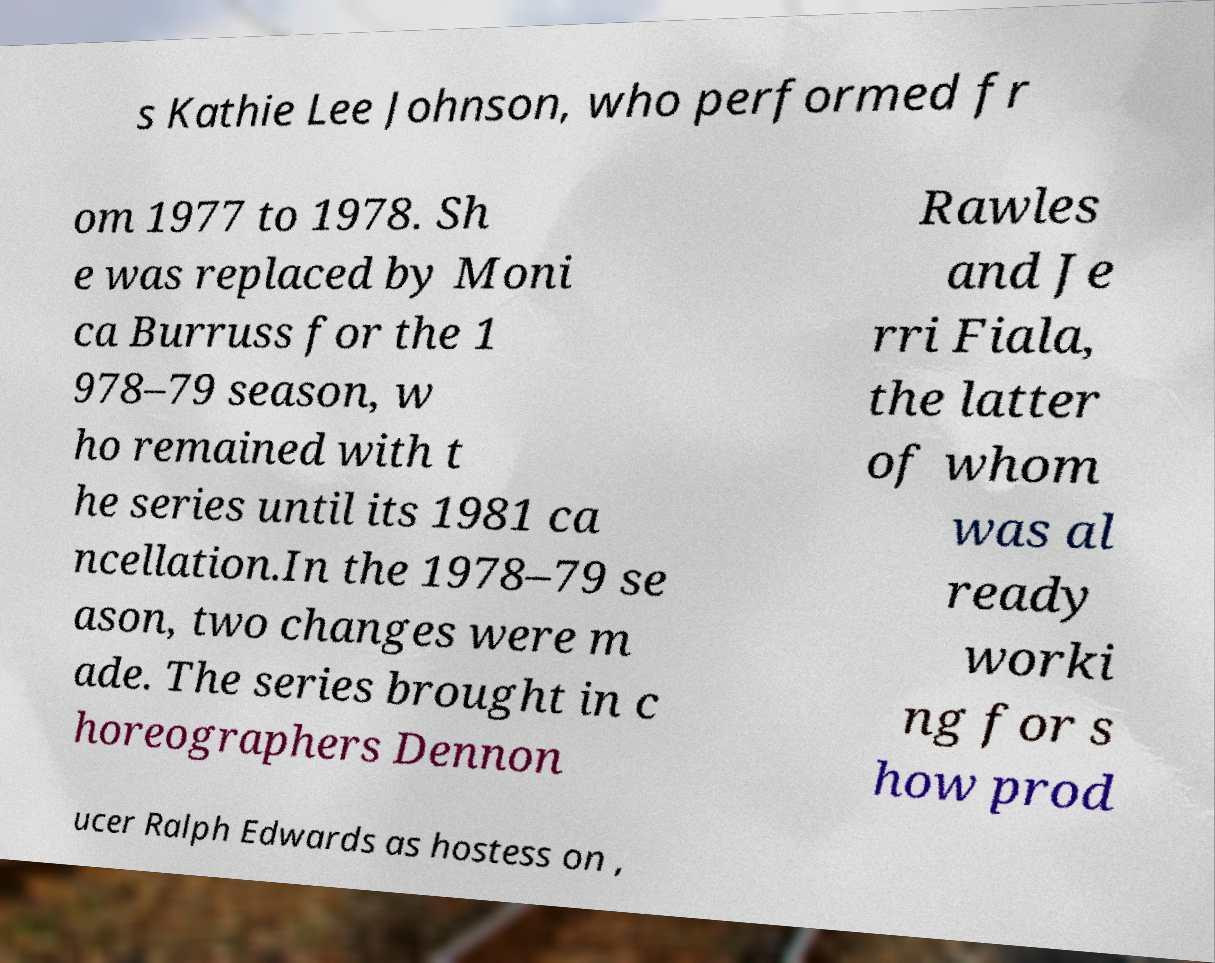Please read and relay the text visible in this image. What does it say? s Kathie Lee Johnson, who performed fr om 1977 to 1978. Sh e was replaced by Moni ca Burruss for the 1 978–79 season, w ho remained with t he series until its 1981 ca ncellation.In the 1978–79 se ason, two changes were m ade. The series brought in c horeographers Dennon Rawles and Je rri Fiala, the latter of whom was al ready worki ng for s how prod ucer Ralph Edwards as hostess on , 